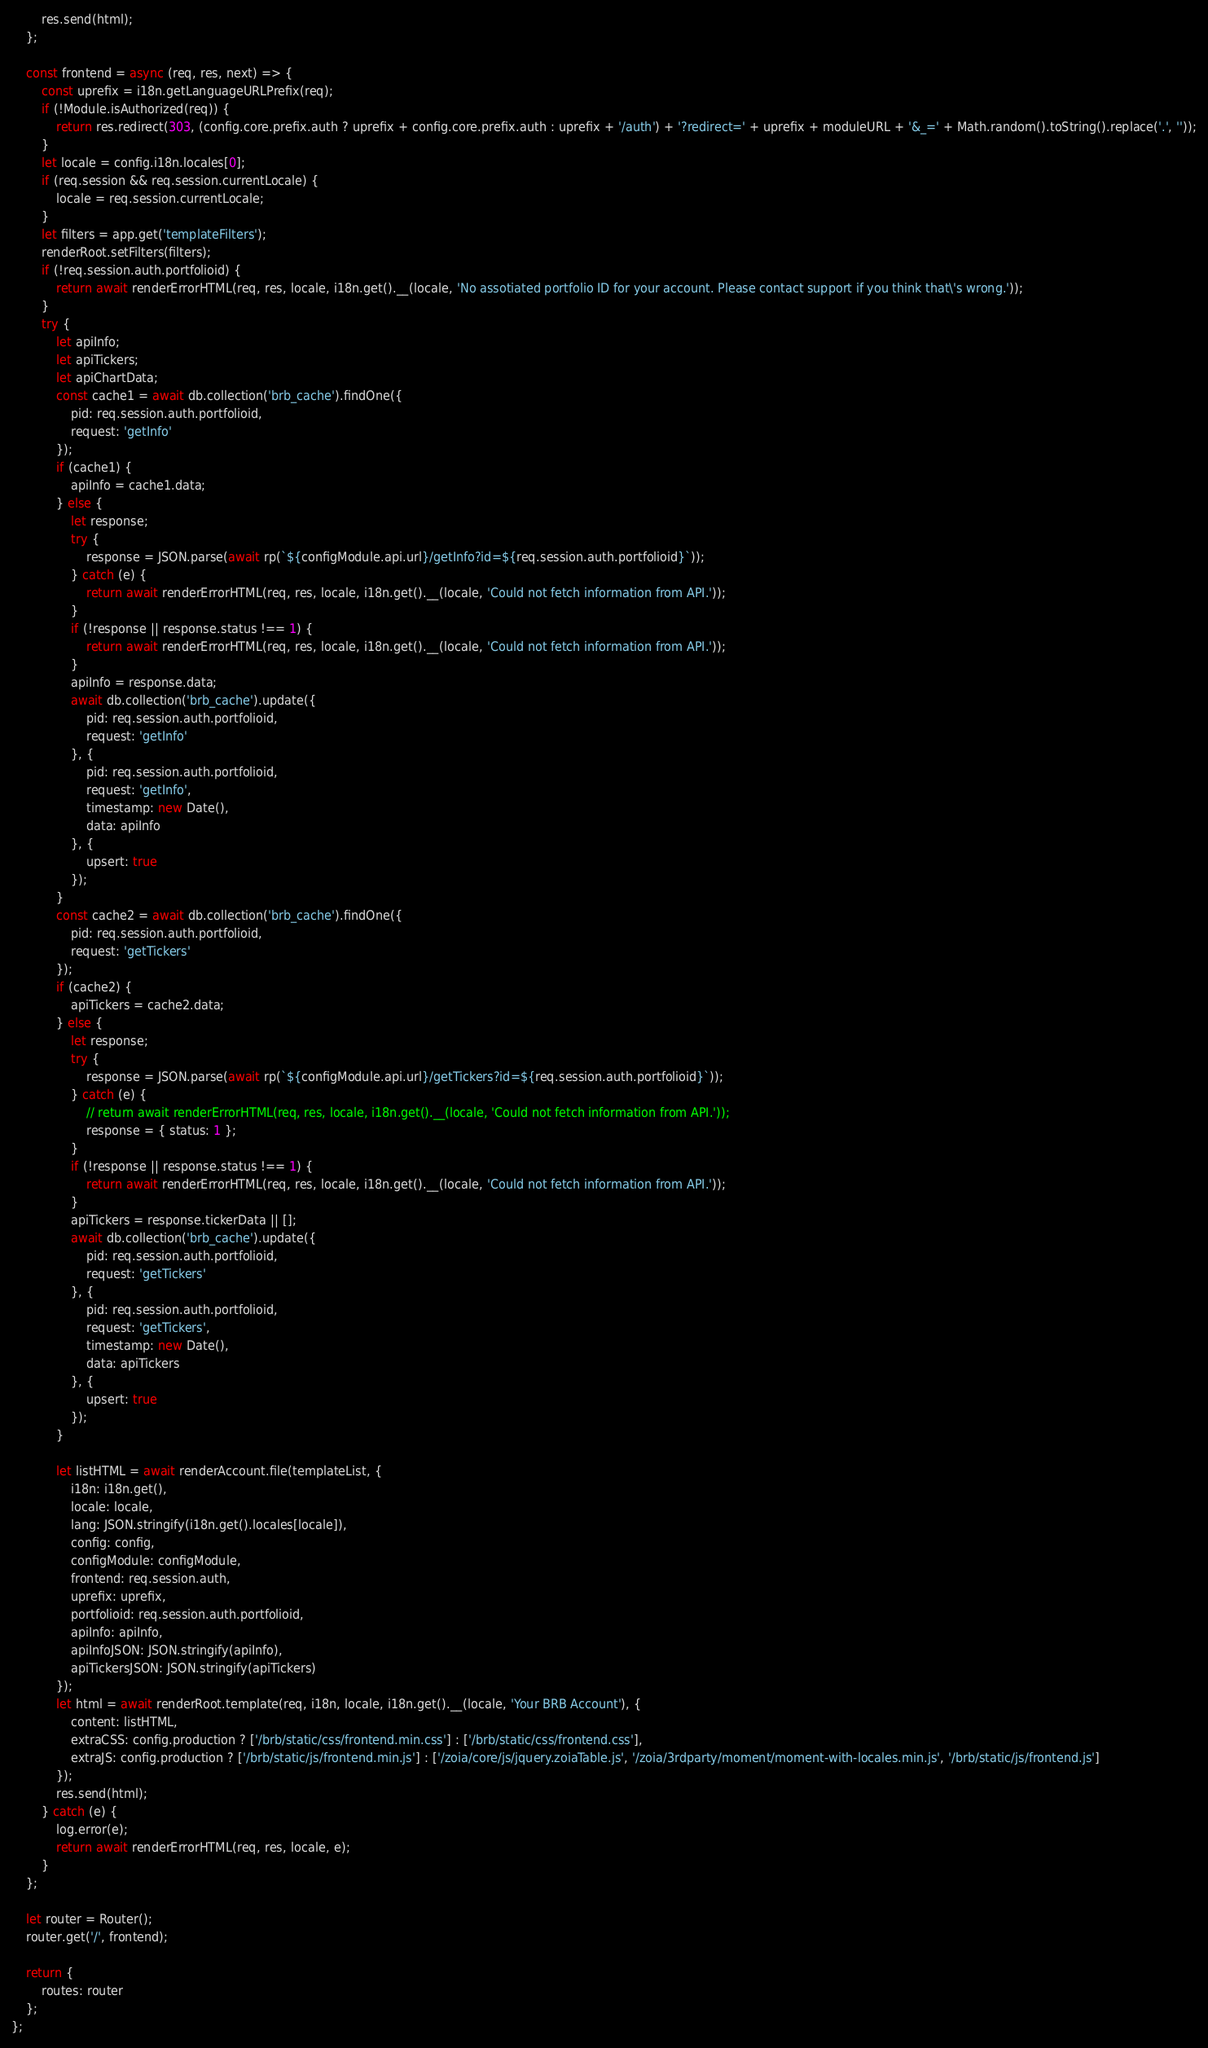Convert code to text. <code><loc_0><loc_0><loc_500><loc_500><_JavaScript_>        res.send(html);
    };

    const frontend = async (req, res, next) => {
        const uprefix = i18n.getLanguageURLPrefix(req);
        if (!Module.isAuthorized(req)) {
            return res.redirect(303, (config.core.prefix.auth ? uprefix + config.core.prefix.auth : uprefix + '/auth') + '?redirect=' + uprefix + moduleURL + '&_=' + Math.random().toString().replace('.', ''));
        }
        let locale = config.i18n.locales[0];
        if (req.session && req.session.currentLocale) {
            locale = req.session.currentLocale;
        }
        let filters = app.get('templateFilters');
        renderRoot.setFilters(filters);
        if (!req.session.auth.portfolioid) {
            return await renderErrorHTML(req, res, locale, i18n.get().__(locale, 'No assotiated portfolio ID for your account. Please contact support if you think that\'s wrong.'));
        }
        try {
            let apiInfo;
            let apiTickers;
            let apiChartData;
            const cache1 = await db.collection('brb_cache').findOne({
                pid: req.session.auth.portfolioid,
                request: 'getInfo'
            });
            if (cache1) {
                apiInfo = cache1.data;
            } else {
                let response;
                try {
                    response = JSON.parse(await rp(`${configModule.api.url}/getInfo?id=${req.session.auth.portfolioid}`));
                } catch (e) {
                    return await renderErrorHTML(req, res, locale, i18n.get().__(locale, 'Could not fetch information from API.'));
                }
                if (!response || response.status !== 1) {
                    return await renderErrorHTML(req, res, locale, i18n.get().__(locale, 'Could not fetch information from API.'));
                }
                apiInfo = response.data;
                await db.collection('brb_cache').update({
                    pid: req.session.auth.portfolioid,
                    request: 'getInfo'
                }, {
                    pid: req.session.auth.portfolioid,
                    request: 'getInfo',
                    timestamp: new Date(),
                    data: apiInfo
                }, {
                    upsert: true
                });
            }
            const cache2 = await db.collection('brb_cache').findOne({
                pid: req.session.auth.portfolioid,
                request: 'getTickers'
            });
            if (cache2) {
                apiTickers = cache2.data;
            } else {
                let response;
                try {
                    response = JSON.parse(await rp(`${configModule.api.url}/getTickers?id=${req.session.auth.portfolioid}`));
                } catch (e) {
                    // return await renderErrorHTML(req, res, locale, i18n.get().__(locale, 'Could not fetch information from API.'));
                    response = { status: 1 };
                }
                if (!response || response.status !== 1) {
                    return await renderErrorHTML(req, res, locale, i18n.get().__(locale, 'Could not fetch information from API.'));
                }
                apiTickers = response.tickerData || [];
                await db.collection('brb_cache').update({
                    pid: req.session.auth.portfolioid,
                    request: 'getTickers'
                }, {
                    pid: req.session.auth.portfolioid,
                    request: 'getTickers',
                    timestamp: new Date(),
                    data: apiTickers
                }, {
                    upsert: true
                });
            }

            let listHTML = await renderAccount.file(templateList, {
                i18n: i18n.get(),
                locale: locale,
                lang: JSON.stringify(i18n.get().locales[locale]),
                config: config,
                configModule: configModule,
                frontend: req.session.auth,
                uprefix: uprefix,
                portfolioid: req.session.auth.portfolioid,
                apiInfo: apiInfo,
                apiInfoJSON: JSON.stringify(apiInfo),
                apiTickersJSON: JSON.stringify(apiTickers)
            });
            let html = await renderRoot.template(req, i18n, locale, i18n.get().__(locale, 'Your BRB Account'), {
                content: listHTML,
                extraCSS: config.production ? ['/brb/static/css/frontend.min.css'] : ['/brb/static/css/frontend.css'],
                extraJS: config.production ? ['/brb/static/js/frontend.min.js'] : ['/zoia/core/js/jquery.zoiaTable.js', '/zoia/3rdparty/moment/moment-with-locales.min.js', '/brb/static/js/frontend.js']
            });
            res.send(html);
        } catch (e) {
            log.error(e);
            return await renderErrorHTML(req, res, locale, e);
        }
    };

    let router = Router();
    router.get('/', frontend);

    return {
        routes: router
    };
};</code> 